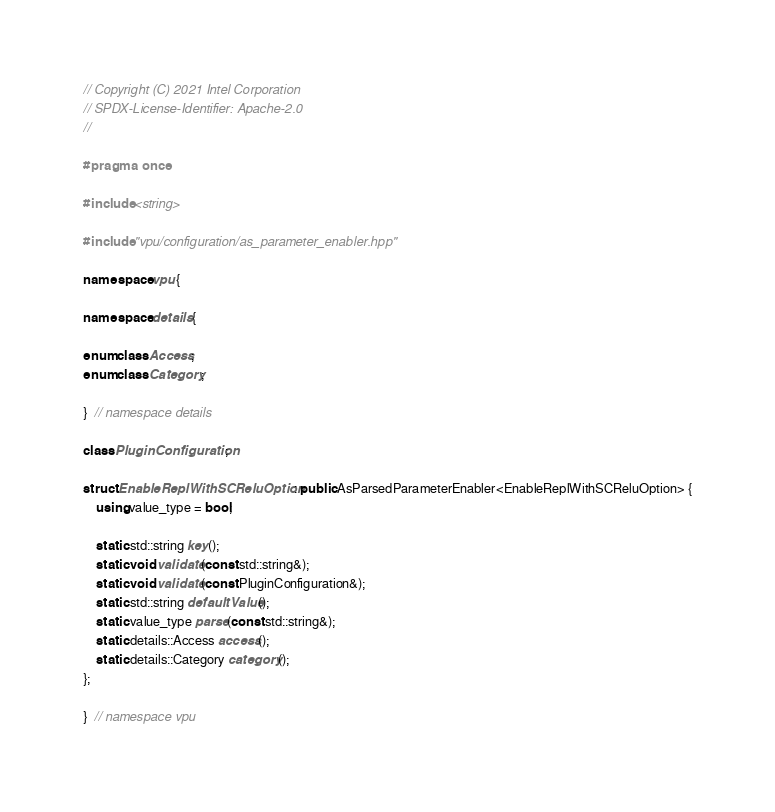Convert code to text. <code><loc_0><loc_0><loc_500><loc_500><_C++_>// Copyright (C) 2021 Intel Corporation
// SPDX-License-Identifier: Apache-2.0
//

#pragma once

#include <string>

#include "vpu/configuration/as_parameter_enabler.hpp"

namespace vpu {

namespace details {

enum class Access;
enum class Category;

}  // namespace details

class PluginConfiguration;

struct EnableReplWithSCReluOption : public AsParsedParameterEnabler<EnableReplWithSCReluOption> {
    using value_type = bool;

    static std::string key();
    static void validate(const std::string&);
    static void validate(const PluginConfiguration&);
    static std::string defaultValue();
    static value_type parse(const std::string&);
    static details::Access access();
    static details::Category category();
};

}  // namespace vpu
</code> 